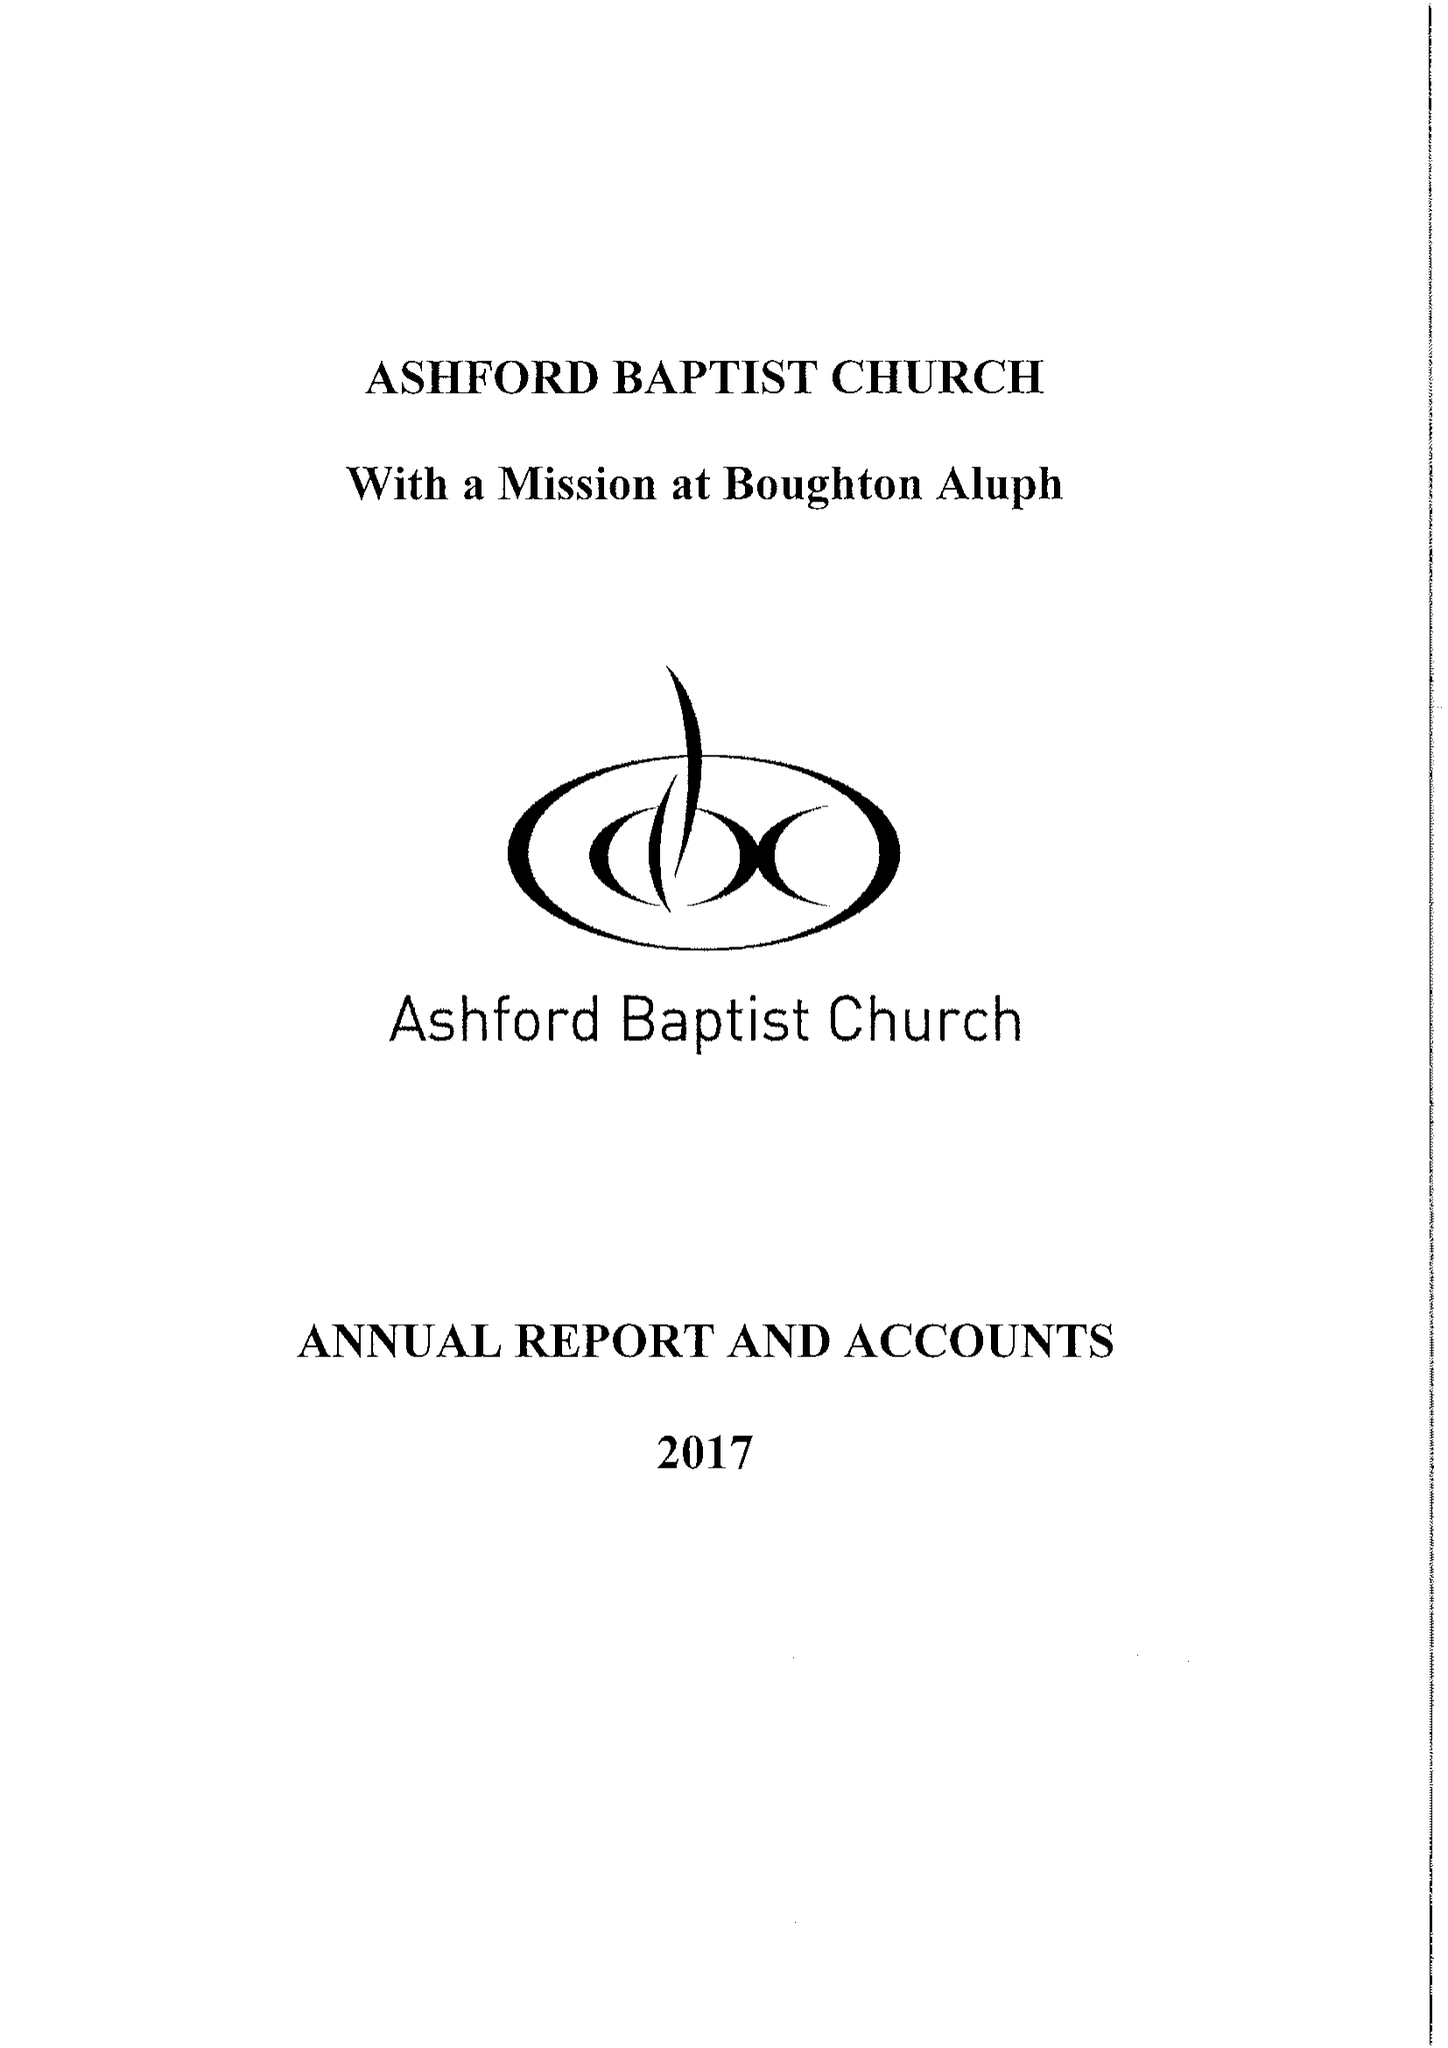What is the value for the income_annually_in_british_pounds?
Answer the question using a single word or phrase. 175358.00 